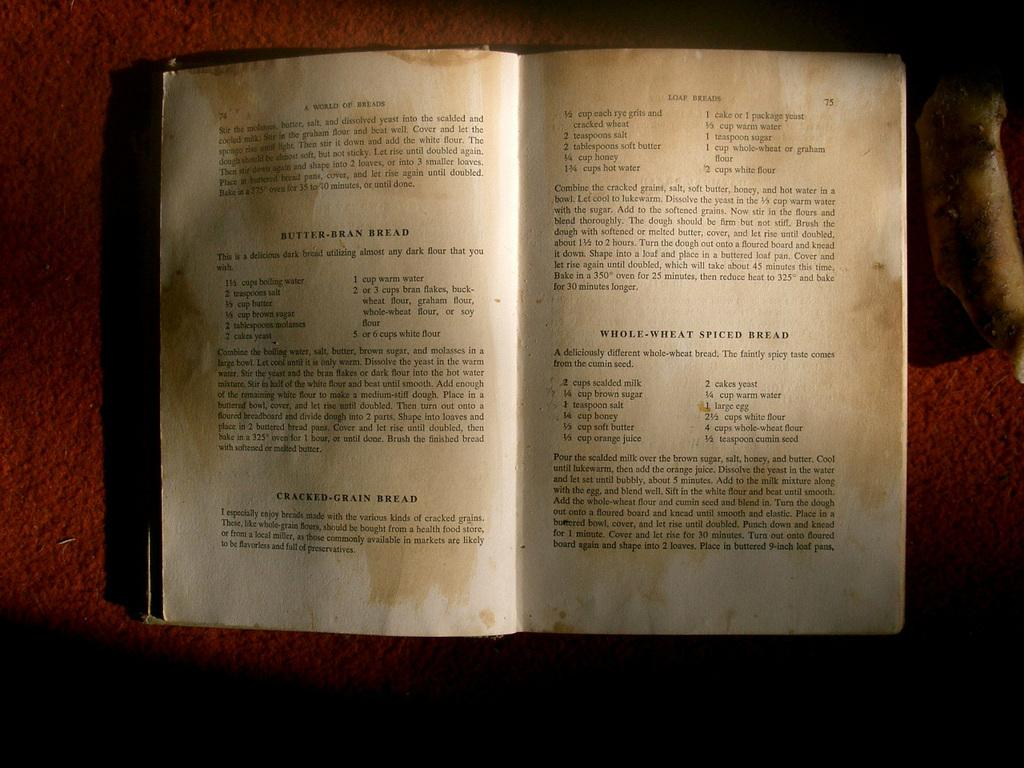<image>
Provide a brief description of the given image. an open book with different recipes on it like butter bran bread. 